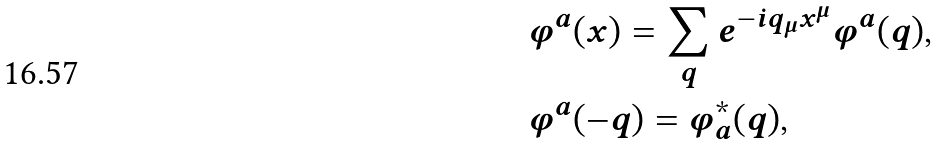Convert formula to latex. <formula><loc_0><loc_0><loc_500><loc_500>& \varphi ^ { a } ( x ) = \sum _ { q } e ^ { - i q _ { \mu } x ^ { \mu } } \varphi ^ { a } ( q ) , \\ & \varphi ^ { a } ( - q ) = \varphi _ { a } ^ { \ast } ( q ) ,</formula> 